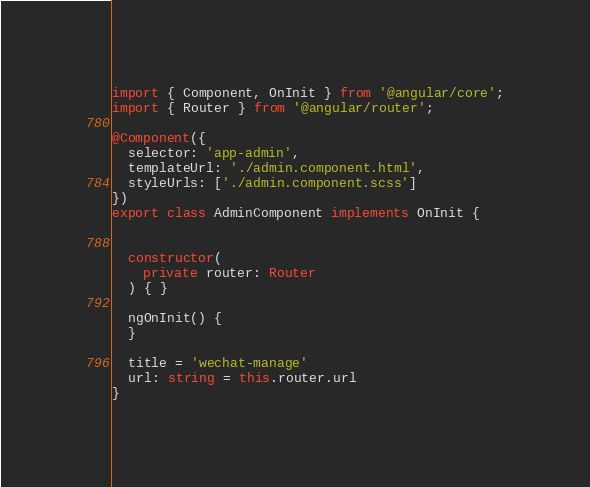Convert code to text. <code><loc_0><loc_0><loc_500><loc_500><_TypeScript_>import { Component, OnInit } from '@angular/core';
import { Router } from '@angular/router';

@Component({
  selector: 'app-admin',
  templateUrl: './admin.component.html',
  styleUrls: ['./admin.component.scss']
})
export class AdminComponent implements OnInit {

  
  constructor(
    private router: Router
  ) { }

  ngOnInit() {
  }

  title = 'wechat-manage'
  url: string = this.router.url
}
</code> 